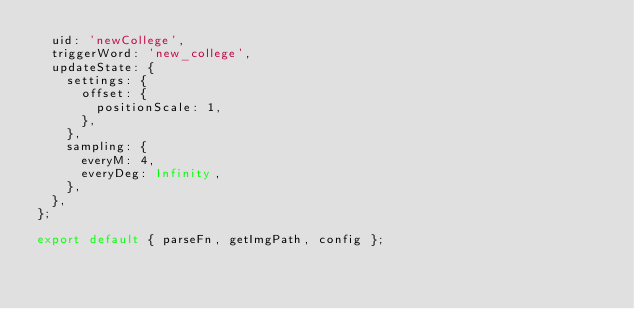<code> <loc_0><loc_0><loc_500><loc_500><_JavaScript_>  uid: 'newCollege',
  triggerWord: 'new_college',
  updateState: {
    settings: {
      offset: {
        positionScale: 1,
      },
    },
    sampling: {
      everyM: 4,
      everyDeg: Infinity,
    },
  },
};

export default { parseFn, getImgPath, config };
</code> 